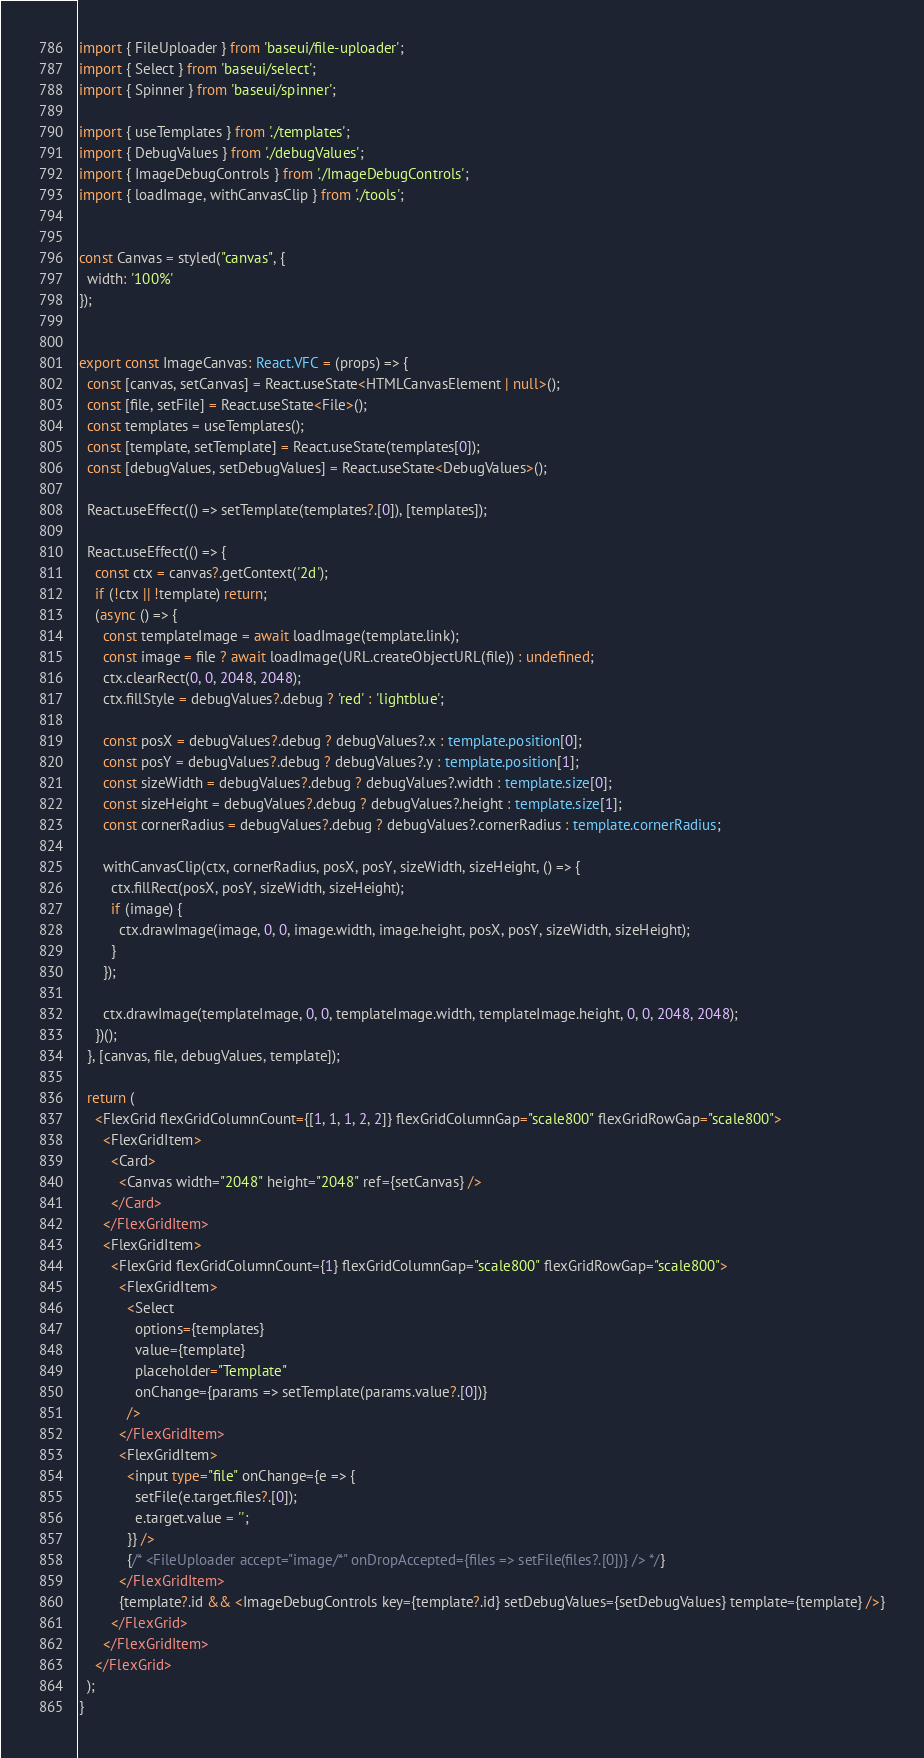Convert code to text. <code><loc_0><loc_0><loc_500><loc_500><_TypeScript_>import { FileUploader } from 'baseui/file-uploader';
import { Select } from 'baseui/select';
import { Spinner } from 'baseui/spinner';

import { useTemplates } from './templates';
import { DebugValues } from './debugValues';
import { ImageDebugControls } from './ImageDebugControls';
import { loadImage, withCanvasClip } from './tools';


const Canvas = styled("canvas", {
  width: '100%'
});


export const ImageCanvas: React.VFC = (props) => {
  const [canvas, setCanvas] = React.useState<HTMLCanvasElement | null>();
  const [file, setFile] = React.useState<File>();
  const templates = useTemplates();
  const [template, setTemplate] = React.useState(templates[0]);
  const [debugValues, setDebugValues] = React.useState<DebugValues>();

  React.useEffect(() => setTemplate(templates?.[0]), [templates]);

  React.useEffect(() => {
    const ctx = canvas?.getContext('2d');
    if (!ctx || !template) return;
    (async () => {
      const templateImage = await loadImage(template.link);
      const image = file ? await loadImage(URL.createObjectURL(file)) : undefined;
      ctx.clearRect(0, 0, 2048, 2048);
      ctx.fillStyle = debugValues?.debug ? 'red' : 'lightblue';

      const posX = debugValues?.debug ? debugValues?.x : template.position[0];
      const posY = debugValues?.debug ? debugValues?.y : template.position[1];
      const sizeWidth = debugValues?.debug ? debugValues?.width : template.size[0];
      const sizeHeight = debugValues?.debug ? debugValues?.height : template.size[1];
      const cornerRadius = debugValues?.debug ? debugValues?.cornerRadius : template.cornerRadius;

      withCanvasClip(ctx, cornerRadius, posX, posY, sizeWidth, sizeHeight, () => {
        ctx.fillRect(posX, posY, sizeWidth, sizeHeight);
        if (image) {
          ctx.drawImage(image, 0, 0, image.width, image.height, posX, posY, sizeWidth, sizeHeight);
        }
      });

      ctx.drawImage(templateImage, 0, 0, templateImage.width, templateImage.height, 0, 0, 2048, 2048);
    })();
  }, [canvas, file, debugValues, template]);

  return (
    <FlexGrid flexGridColumnCount={[1, 1, 1, 2, 2]} flexGridColumnGap="scale800" flexGridRowGap="scale800">
      <FlexGridItem>
        <Card>
          <Canvas width="2048" height="2048" ref={setCanvas} />
        </Card>
      </FlexGridItem>
      <FlexGridItem>
        <FlexGrid flexGridColumnCount={1} flexGridColumnGap="scale800" flexGridRowGap="scale800">
          <FlexGridItem>
            <Select
              options={templates}
              value={template}
              placeholder="Template"
              onChange={params => setTemplate(params.value?.[0])}
            />
          </FlexGridItem>
          <FlexGridItem>
            <input type="file" onChange={e => {
              setFile(e.target.files?.[0]);
              e.target.value = '';
            }} />
            {/* <FileUploader accept="image/*" onDropAccepted={files => setFile(files?.[0])} /> */}
          </FlexGridItem>
          {template?.id && <ImageDebugControls key={template?.id} setDebugValues={setDebugValues} template={template} />}
        </FlexGrid>
      </FlexGridItem>
    </FlexGrid>
  );
}</code> 